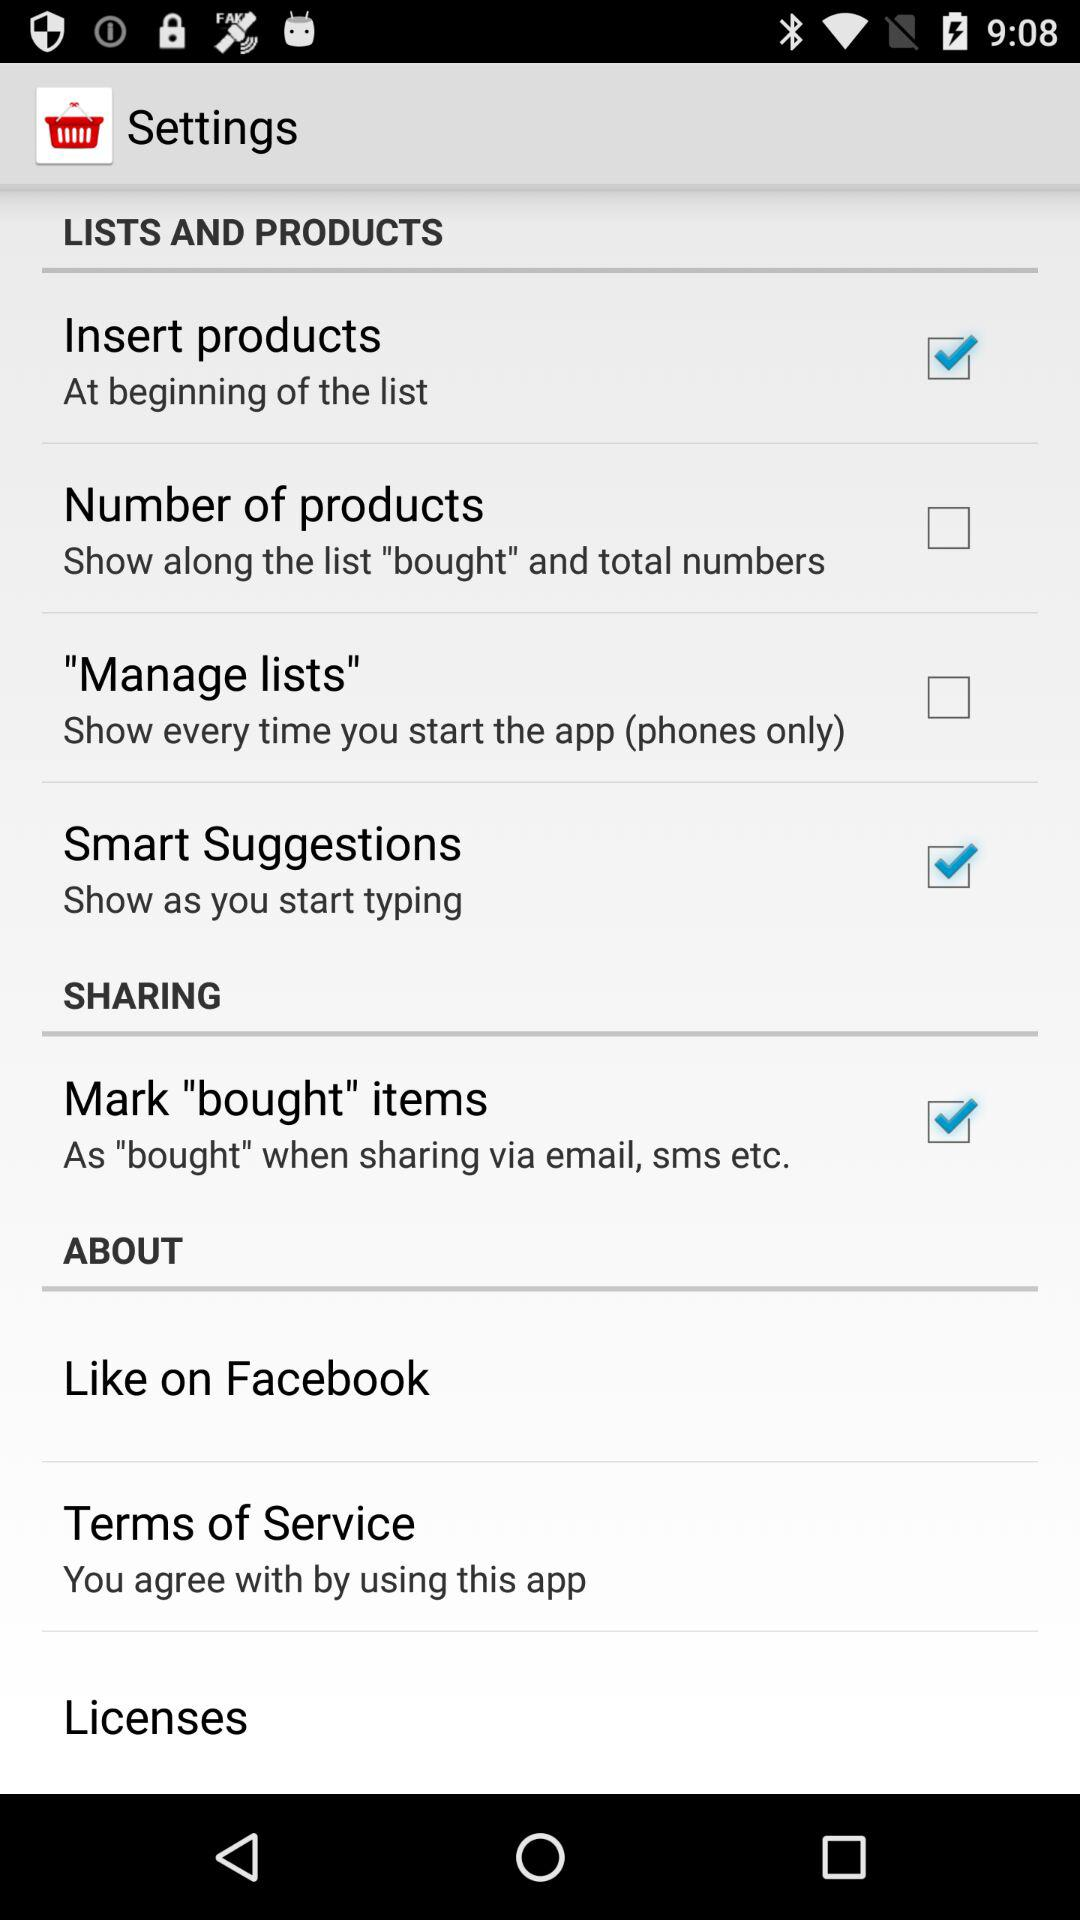What is the status of the "Manage lists"? The status is "off". 